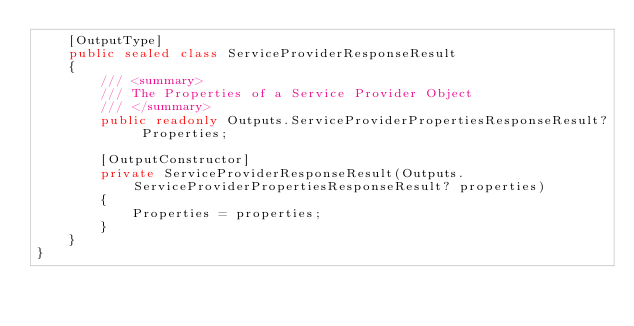Convert code to text. <code><loc_0><loc_0><loc_500><loc_500><_C#_>    [OutputType]
    public sealed class ServiceProviderResponseResult
    {
        /// <summary>
        /// The Properties of a Service Provider Object
        /// </summary>
        public readonly Outputs.ServiceProviderPropertiesResponseResult? Properties;

        [OutputConstructor]
        private ServiceProviderResponseResult(Outputs.ServiceProviderPropertiesResponseResult? properties)
        {
            Properties = properties;
        }
    }
}
</code> 